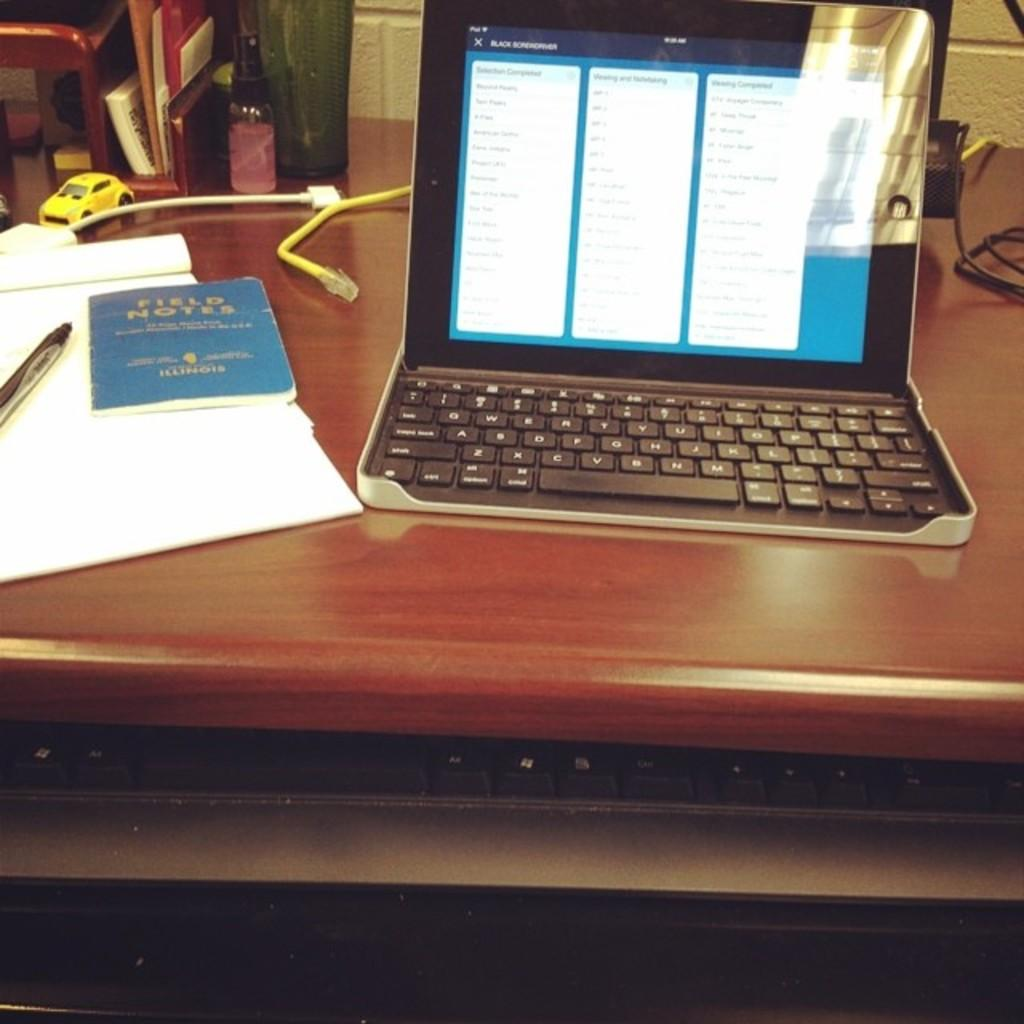What piece of furniture is present in the image? There is a table in the image. What electronic device is on the table? There is a laptop on the table. What reading material is on the table? There is a book on the table. What writing material is on the table? There is a paper on the table. What type of object is not for work or reading in the image? There is a toy in the image. Where is the pail of water in the image? There is no pail of water present in the image. What type of dust is visible on the laptop in the image? There is no dust visible on the laptop in the image. 